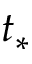Convert formula to latex. <formula><loc_0><loc_0><loc_500><loc_500>t _ { * }</formula> 